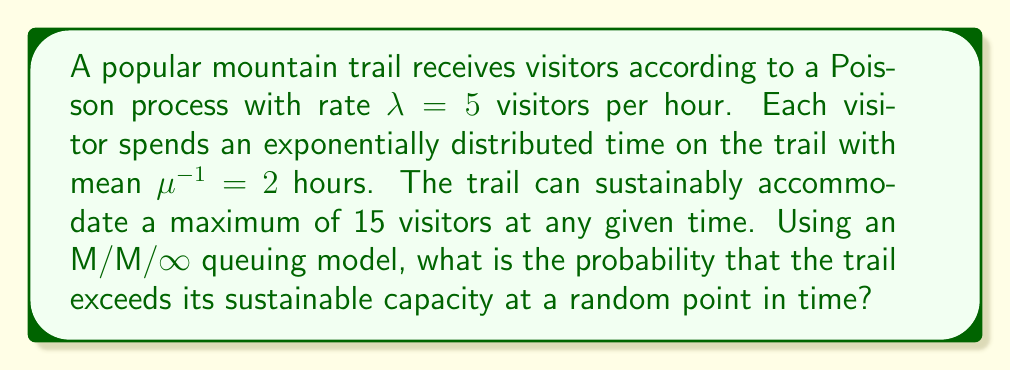Show me your answer to this math problem. Let's approach this step-by-step:

1) First, we recognize that this scenario can be modeled as an M/M/∞ queue, where:
   - Arrivals follow a Poisson process with rate $\lambda = 5$ visitors/hour
   - Service times (time spent on the trail) are exponentially distributed with mean $\mu^{-1} = 2$ hours

2) In an M/M/∞ queue, the number of visitors in the system at steady state follows a Poisson distribution with mean $\rho = \frac{\lambda}{\mu}$

3) Calculate $\rho$:
   $\rho = \lambda \cdot \mu^{-1} = 5 \cdot 2 = 10$

4) The probability of exceeding the sustainable capacity is the probability of having more than 15 visitors on the trail. This is equivalent to 1 minus the probability of having 15 or fewer visitors.

5) For a Poisson distribution with mean $\rho$, the probability of $k$ or fewer occurrences is given by the cumulative distribution function:

   $$P(X \leq k) = e^{-\rho} \sum_{i=0}^k \frac{\rho^i}{i!}$$

6) Therefore, the probability of exceeding the sustainable capacity is:

   $$P(X > 15) = 1 - P(X \leq 15) = 1 - e^{-10} \sum_{i=0}^{15} \frac{10^i}{i!}$$

7) This can be calculated using statistical software or a calculator with a cumulative Poisson distribution function.
Answer: $1 - e^{-10} \sum_{i=0}^{15} \frac{10^i}{i!} \approx 0.0897$ 